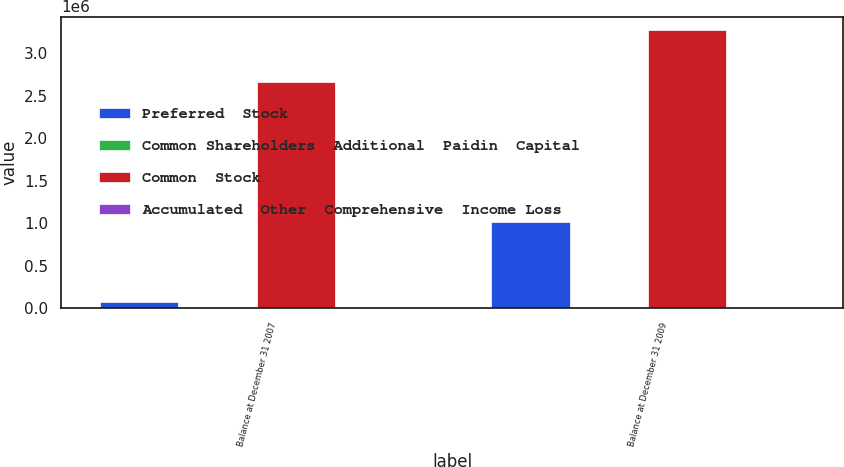Convert chart. <chart><loc_0><loc_0><loc_500><loc_500><stacked_bar_chart><ecel><fcel>Balance at December 31 2007<fcel>Balance at December 31 2009<nl><fcel>Preferred  Stock<fcel>74400<fcel>1.01662e+06<nl><fcel>Common Shareholders  Additional  Paidin  Capital<fcel>1462<fcel>2240<nl><fcel>Common  Stock<fcel>2.66729e+06<fcel>3.2672e+06<nl><fcel>Accumulated  Other  Comprehensive  Income Loss<fcel>1279<fcel>5630<nl></chart> 